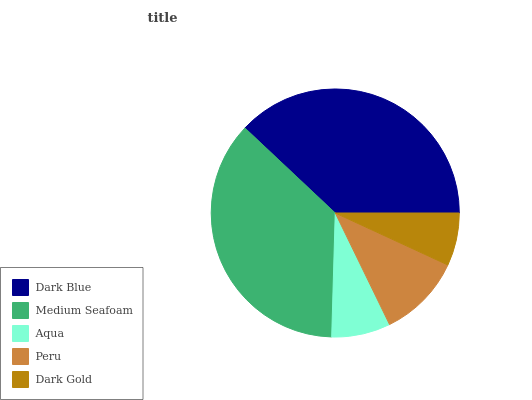Is Dark Gold the minimum?
Answer yes or no. Yes. Is Dark Blue the maximum?
Answer yes or no. Yes. Is Medium Seafoam the minimum?
Answer yes or no. No. Is Medium Seafoam the maximum?
Answer yes or no. No. Is Dark Blue greater than Medium Seafoam?
Answer yes or no. Yes. Is Medium Seafoam less than Dark Blue?
Answer yes or no. Yes. Is Medium Seafoam greater than Dark Blue?
Answer yes or no. No. Is Dark Blue less than Medium Seafoam?
Answer yes or no. No. Is Peru the high median?
Answer yes or no. Yes. Is Peru the low median?
Answer yes or no. Yes. Is Dark Blue the high median?
Answer yes or no. No. Is Medium Seafoam the low median?
Answer yes or no. No. 